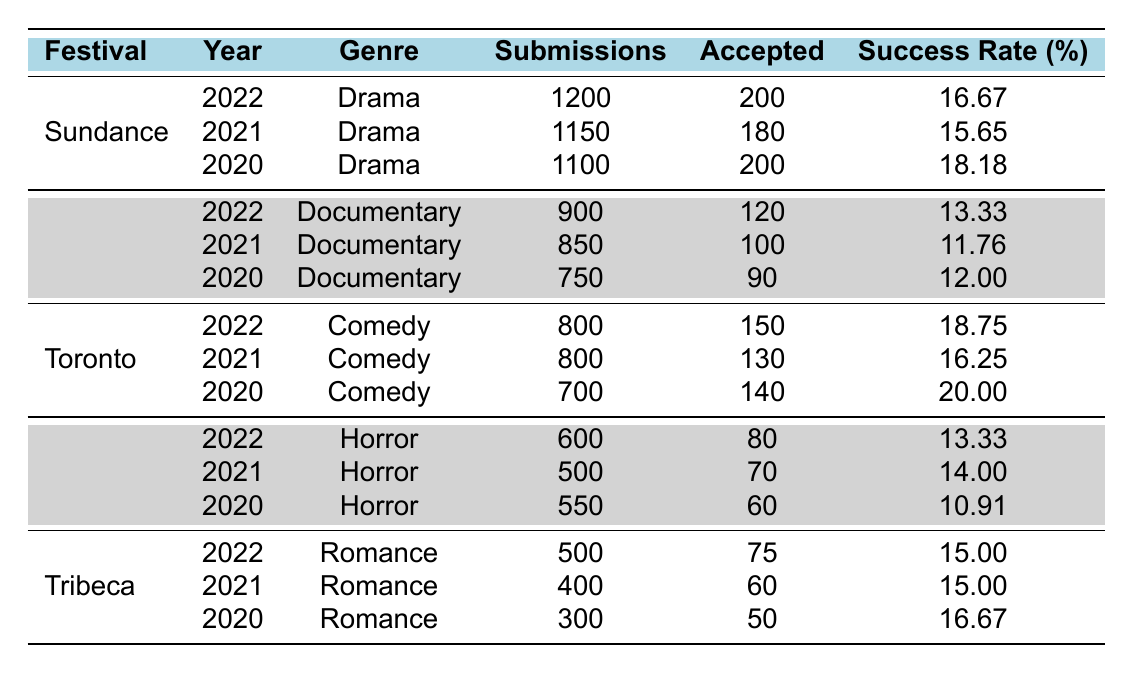What was the success rate for Comedy submissions at the Toronto International Film Festival in 2022? The table shows that for the Toronto International Film Festival in 2022, the success rate for Comedy submissions is listed as 18.75%.
Answer: 18.75% Which festival had the highest success rate for Drama submissions in 2020? Looking at the table, the Sundance Film Festival had a success rate of 18.18% for Drama submissions in 2020. The other festivals listed for Drama in 2020 do not have a higher success rate.
Answer: Sundance Film Festival What is the average success rate for Documentary submissions over the three years at the Cannes Film Festival? The success rates for Documentary submissions at Cannes are 13.33% (2022), 11.76% (2021), and 12.00% (2020). Adding these gives 13.33 + 11.76 + 12.00 = 37.09. Then, dividing by 3 gives 37.09 / 3 = 12.36.
Answer: 12.36% Did the success rate for Horror submissions at the Berlin International Film Festival improve from 2020 to 2022? The success rate for Horror submissions at Berlin in 2020 was 10.91%, and in 2022 it was 13.33%. Since 13.33% is greater than 10.91%, the success rate did improve.
Answer: Yes Which genre had the most accepted submissions at the Toronto International Film Festival in 2021? For the Toronto International Film Festival in 2021, the accepted submissions for Comedy was 130. The table does not list any other genres at this festival for that year, so 130 is the highest.
Answer: Comedy How many more submissions were there for Drama at Sundance in 2022 compared to 2021? The submission count for Drama at Sundance in 2022 was 1200, and in 2021 it was 1150. To find the difference, subtract 1150 from 1200, which equals 50.
Answer: 50 What percentage of submissions were accepted for Romance at the Tribeca Film Festival in 2020? For Romance at Tribeca in 2020, there were 300 submissions and 50 accepted. To find the success rate percentage, divide 50 by 300 and multiply by 100, which gives (50 / 300) * 100 = 16.67%.
Answer: 16.67% Was the success rate for Drama submissions higher or lower in 2021 than in 2022 at Sundance? The success rate for Drama at Sundance in 2021 was 15.65%, while in 2022 it was 16.67%. Since 16.67% is higher than 15.65%, the rate increased.
Answer: Higher Which festival had the lowest success rate for Documentary submissions across the three years? The success rates for Documentary submissions at Cannes are 13.33% (2022), 11.76% (2021), and 12.00% (2020). The lowest success rate is 11.76% in 2021.
Answer: Cannes Film Festival in 2021 What was the total number of submissions for Comedy at the Toronto International Film Festival over three years? The total submission count for Comedy at Toronto is the sum of submissions for 2020 (700), 2021 (800), and 2022 (800), which gives 700 + 800 + 800 = 2300.
Answer: 2300 